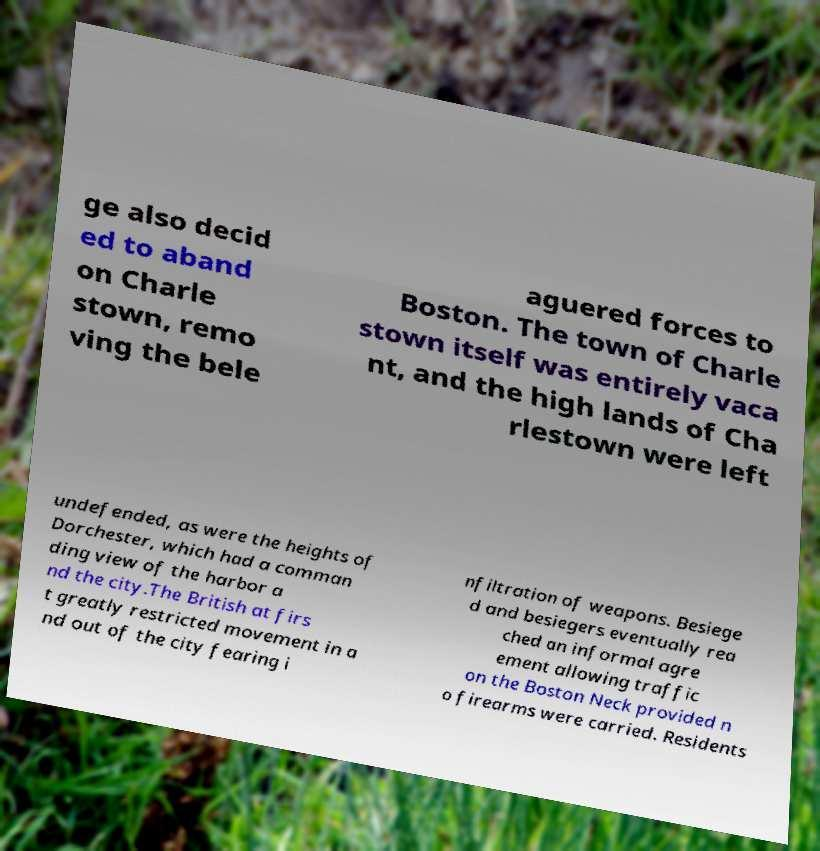Please identify and transcribe the text found in this image. ge also decid ed to aband on Charle stown, remo ving the bele aguered forces to Boston. The town of Charle stown itself was entirely vaca nt, and the high lands of Cha rlestown were left undefended, as were the heights of Dorchester, which had a comman ding view of the harbor a nd the city.The British at firs t greatly restricted movement in a nd out of the city fearing i nfiltration of weapons. Besiege d and besiegers eventually rea ched an informal agre ement allowing traffic on the Boston Neck provided n o firearms were carried. Residents 